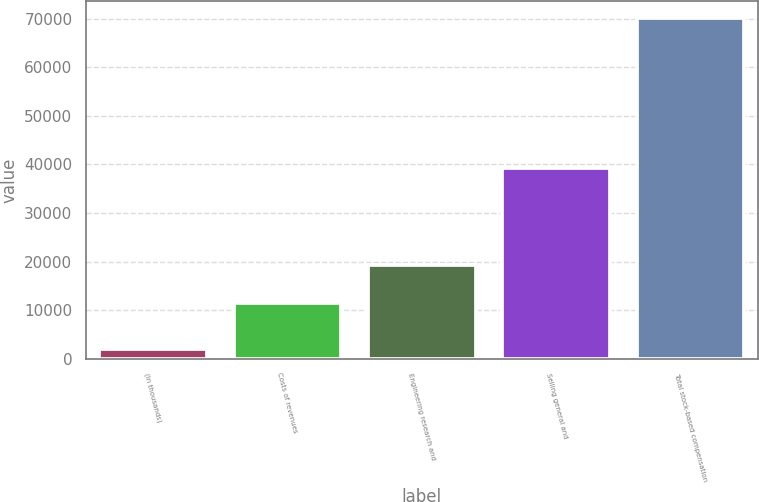Convert chart. <chart><loc_0><loc_0><loc_500><loc_500><bar_chart><fcel>(In thousands)<fcel>Costs of revenues<fcel>Engineering research and<fcel>Selling general and<fcel>Total stock-based compensation<nl><fcel>2013<fcel>11433<fcel>19346<fcel>39305<fcel>70084<nl></chart> 